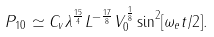<formula> <loc_0><loc_0><loc_500><loc_500>P _ { 1 0 } \simeq C _ { v } \lambda ^ { \frac { 1 5 } { 4 } } L ^ { - \frac { 1 7 } { 8 } } V _ { 0 } ^ { \frac { 1 } { 8 } } \sin ^ { 2 } [ \omega _ { e } t / 2 ] .</formula> 